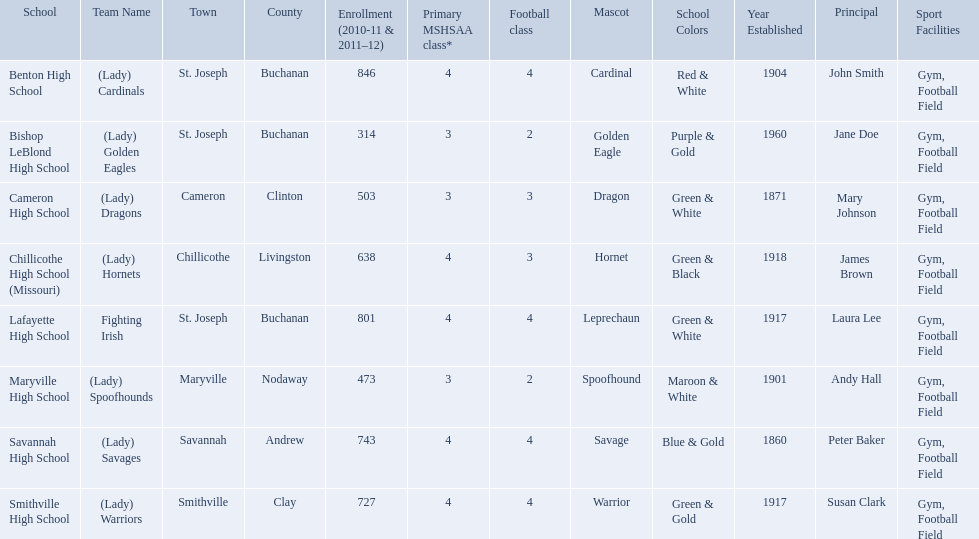What team uses green and grey as colors? Fighting Irish. What is this team called? Lafayette High School. What are the three schools in the town of st. joseph? St. Joseph, St. Joseph, St. Joseph. Of the three schools in st. joseph which school's team name does not depict a type of animal? Lafayette High School. What were the schools enrolled in 2010-2011 Benton High School, Bishop LeBlond High School, Cameron High School, Chillicothe High School (Missouri), Lafayette High School, Maryville High School, Savannah High School, Smithville High School. How many were enrolled in each? 846, 314, 503, 638, 801, 473, 743, 727. Which is the lowest number? 314. Which school had this number of students? Bishop LeBlond High School. 